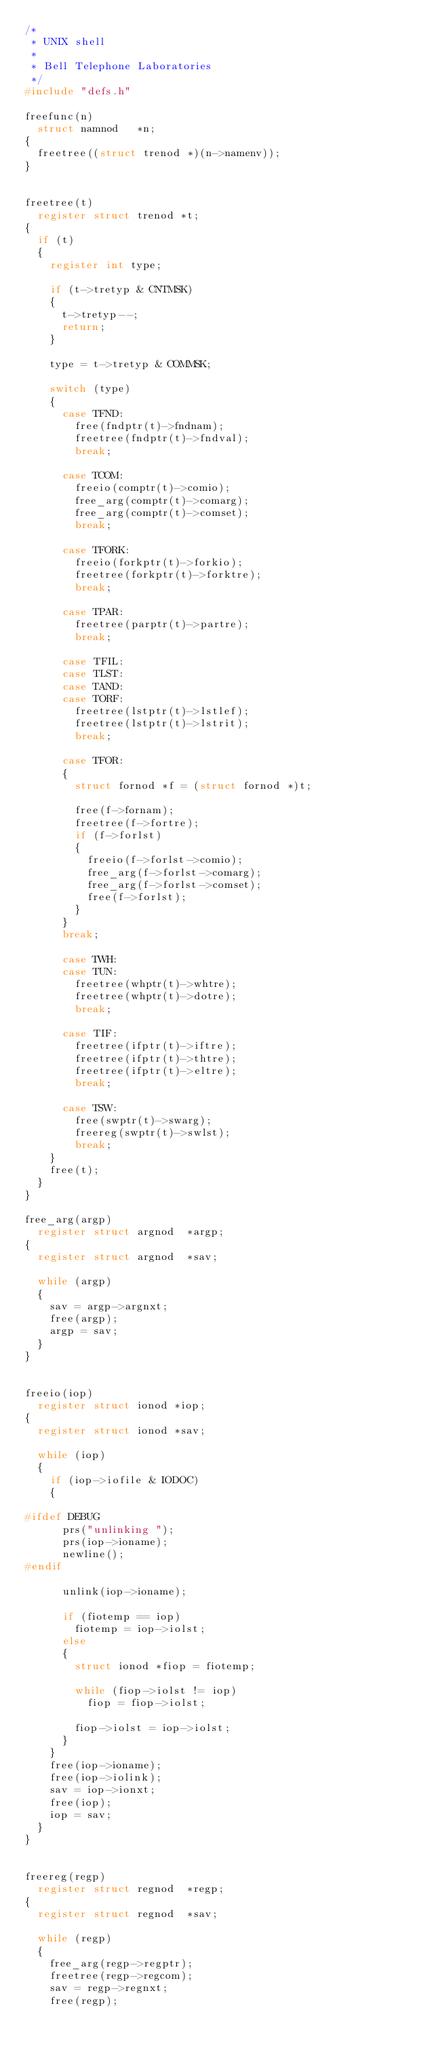Convert code to text. <code><loc_0><loc_0><loc_500><loc_500><_C_>/*
 * UNIX shell
 *
 * Bell Telephone Laboratories
 */
#include "defs.h"

freefunc(n)
	struct namnod 	*n;
{
	freetree((struct trenod *)(n->namenv));
}


freetree(t)
	register struct trenod *t;
{
	if (t)
	{
		register int type;

		if (t->tretyp & CNTMSK)
		{
			t->tretyp--;
			return;
		}

		type = t->tretyp & COMMSK;

		switch (type)
		{
			case TFND:
				free(fndptr(t)->fndnam);
				freetree(fndptr(t)->fndval);
				break;

			case TCOM:
				freeio(comptr(t)->comio);
				free_arg(comptr(t)->comarg);
				free_arg(comptr(t)->comset);
				break;

			case TFORK:
				freeio(forkptr(t)->forkio);
				freetree(forkptr(t)->forktre);
				break;

			case TPAR:
				freetree(parptr(t)->partre);
				break;

			case TFIL:
			case TLST:
			case TAND:
			case TORF:
				freetree(lstptr(t)->lstlef);
				freetree(lstptr(t)->lstrit);
				break;

			case TFOR:
			{
				struct fornod *f = (struct fornod *)t;

				free(f->fornam);
				freetree(f->fortre);
				if (f->forlst)
				{
					freeio(f->forlst->comio);
					free_arg(f->forlst->comarg);
					free_arg(f->forlst->comset);
					free(f->forlst);
				}
			}
			break;

			case TWH:
			case TUN:
				freetree(whptr(t)->whtre);
				freetree(whptr(t)->dotre);
				break;

			case TIF:
				freetree(ifptr(t)->iftre);
				freetree(ifptr(t)->thtre);
				freetree(ifptr(t)->eltre);
				break;

			case TSW:
				free(swptr(t)->swarg);
				freereg(swptr(t)->swlst);
				break;
		}
		free(t);
	}
}

free_arg(argp)
	register struct argnod 	*argp;
{
	register struct argnod 	*sav;

	while (argp)
	{
		sav = argp->argnxt;
		free(argp);
		argp = sav;
	}
}


freeio(iop)
	register struct ionod *iop;
{
	register struct ionod *sav;

	while (iop)
	{
		if (iop->iofile & IODOC)
		{

#ifdef DEBUG
			prs("unlinking ");
			prs(iop->ioname);
			newline();
#endif

			unlink(iop->ioname);

			if (fiotemp == iop)
				fiotemp = iop->iolst;
			else
			{
				struct ionod *fiop = fiotemp;

				while (fiop->iolst != iop)
					fiop = fiop->iolst;

				fiop->iolst = iop->iolst;
			}
		}
		free(iop->ioname);
		free(iop->iolink);
		sav = iop->ionxt;
		free(iop);
		iop = sav;
	}
}


freereg(regp)
	register struct regnod 	*regp;
{
	register struct regnod 	*sav;

	while (regp)
	{
		free_arg(regp->regptr);
		freetree(regp->regcom);
		sav = regp->regnxt;
		free(regp);</code> 